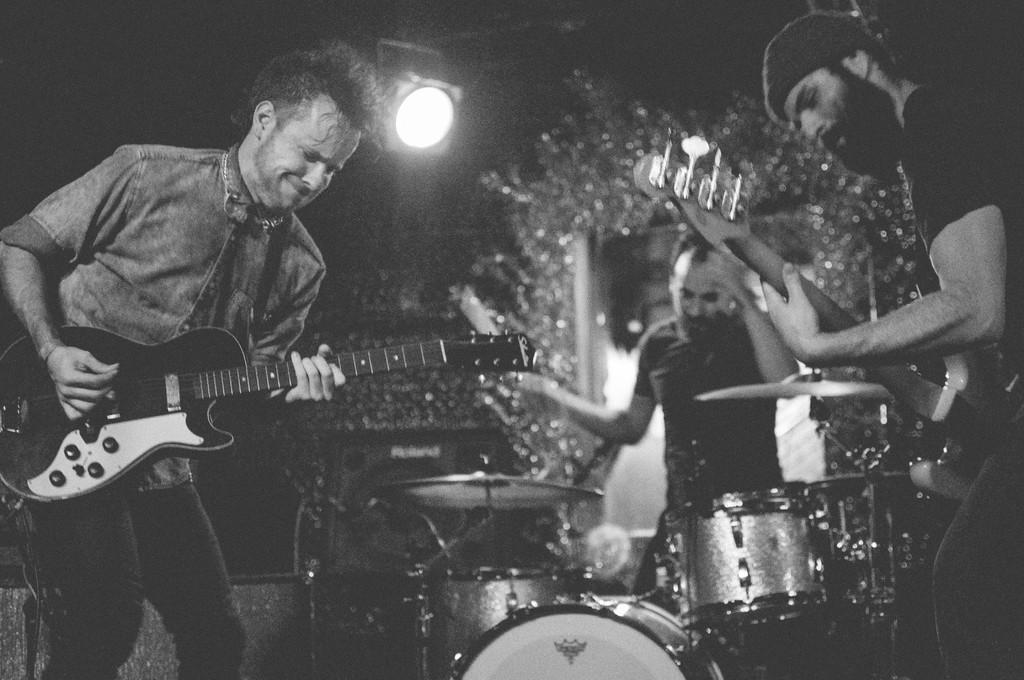Describe this image in one or two sentences. A black and white picture. This persons are playing a musical instruments. On top there is a focusing lights. 